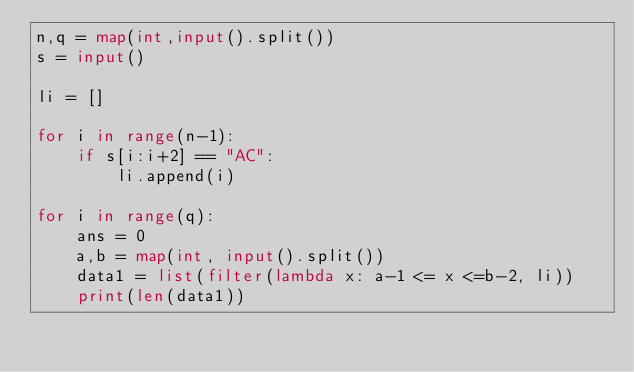Convert code to text. <code><loc_0><loc_0><loc_500><loc_500><_Python_>n,q = map(int,input().split())
s = input()

li = []

for i in range(n-1):
    if s[i:i+2] == "AC":
        li.append(i)

for i in range(q):
    ans = 0
    a,b = map(int, input().split())
    data1 = list(filter(lambda x: a-1 <= x <=b-2, li))
    print(len(data1))</code> 